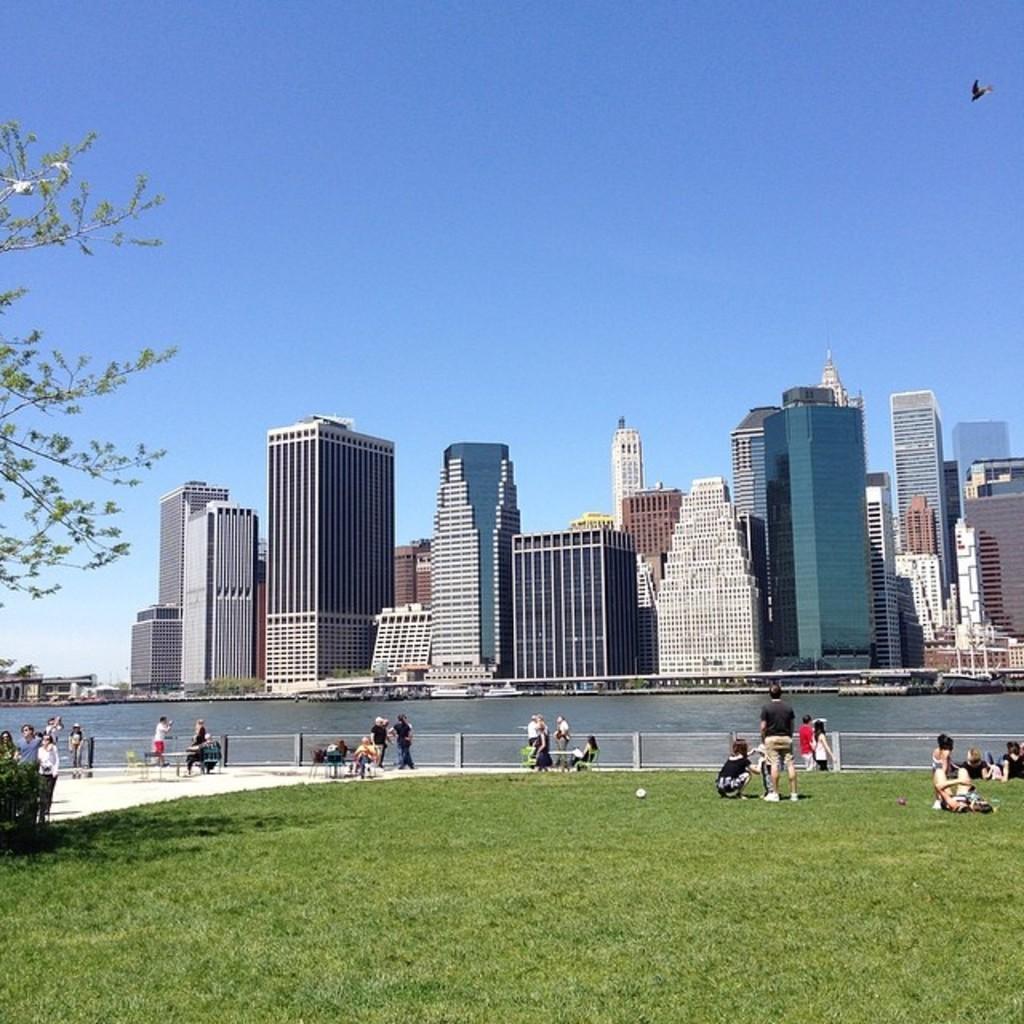In one or two sentences, can you explain what this image depicts? In this image in the center there are some people standing, and some of them are sitting. And at the bottom there is grass and plants, on the grass there are some persons sitting and in the background there is a river, buildings. At the top there is sky and one bird is flying. 